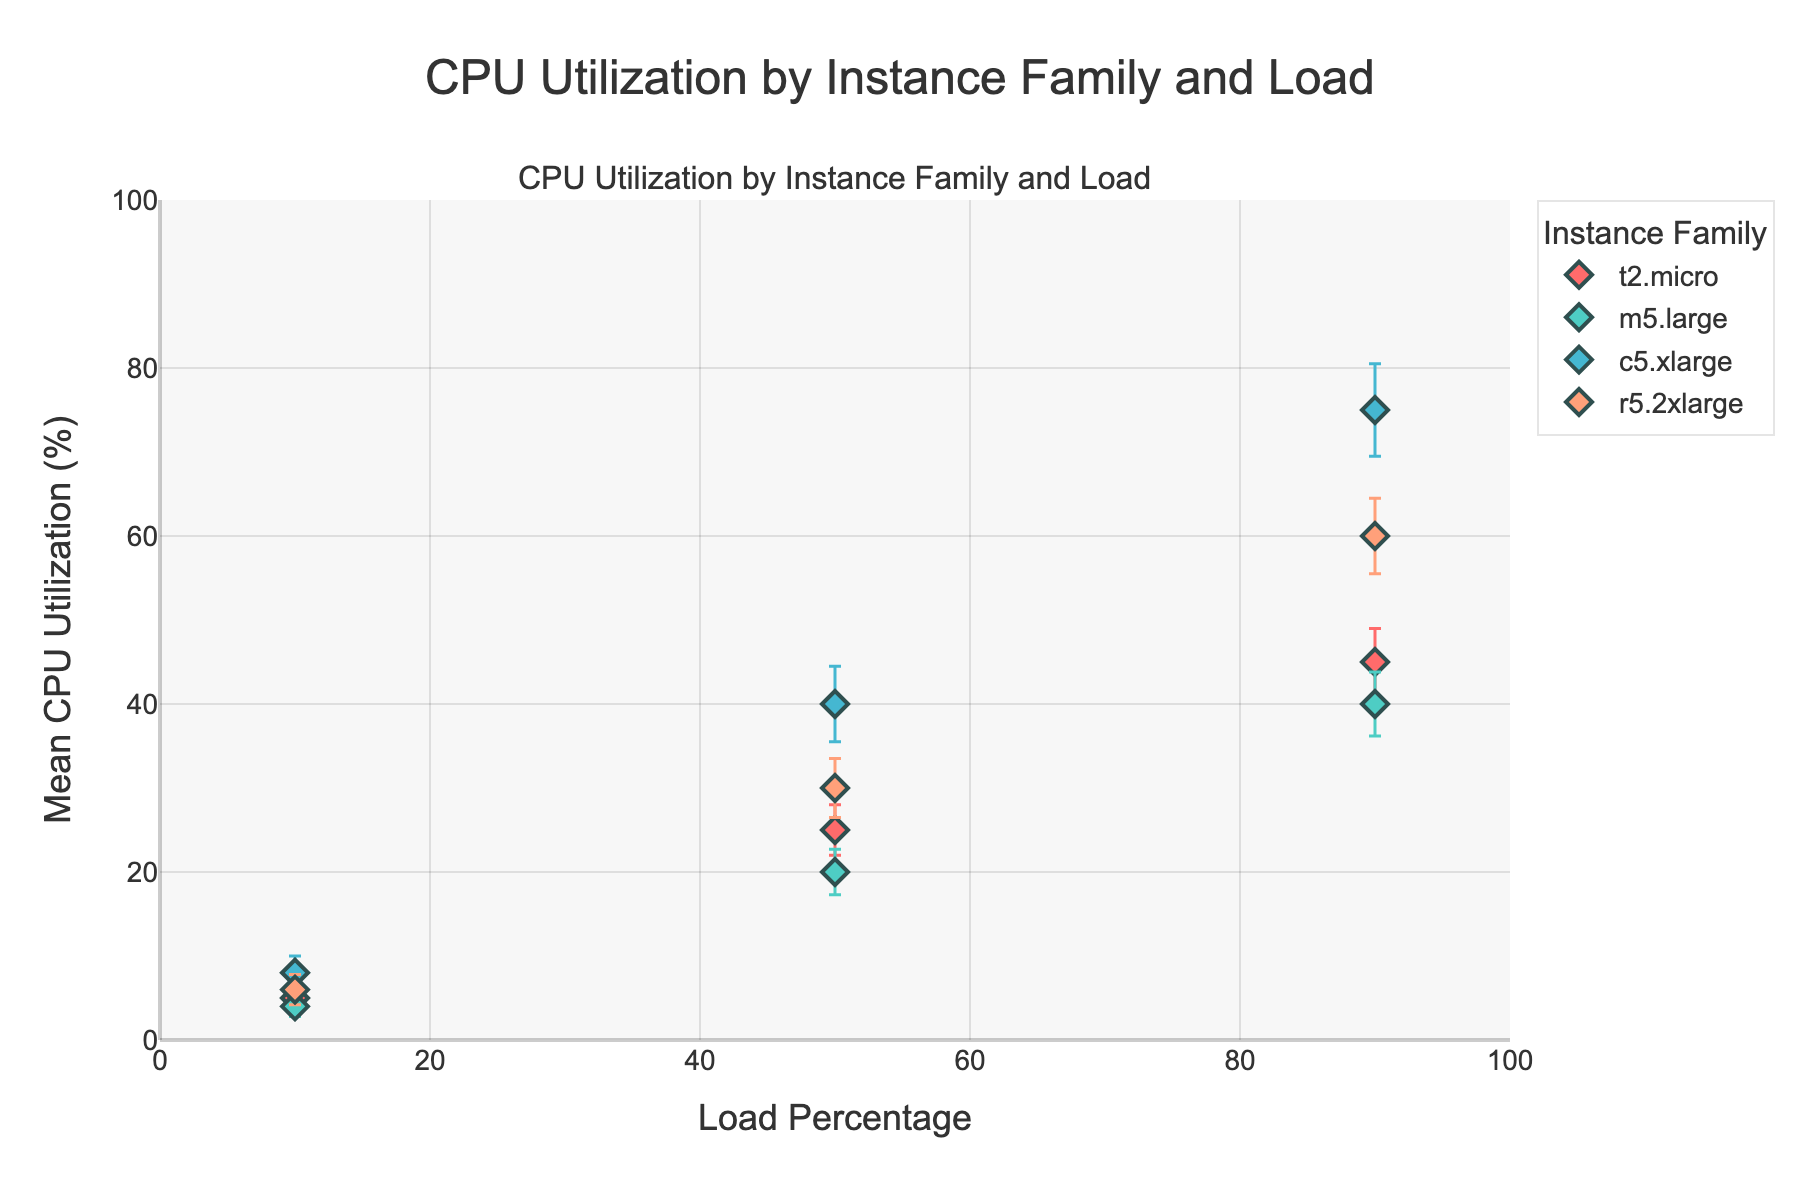What's the title of the plot? The title is displayed at the top of the plot and is usually a concise description of what the plot represents. In this case, it is given in the code.
Answer: CPU Utilization by Instance Family and Load What is the x-axis label? The x-axis label is provided under the horizontal axis of the plot, describing the data it represents. According to the code, it specifies the load percentage.
Answer: Load Percentage Which instance family shows the highest mean CPU utilization at 90% load? To determine this, look at the plotted points for the 90% load on the x-axis and find the highest y-coordinate among them.
Answer: c5.xlarge What is the mean CPU utilization for an m5.large instance at 10% load? Look for the data point associated with the m5.large instance family at 10% load on the plot. The y-value of this point represents the mean CPU utilization.
Answer: 4% Compare the CPU utilization of t2.micro and r5.2xlarge at 50% load. Which is higher? Locate the points for t2.micro and r5.2xlarge at 50% load on the x-axis and compare their y-values.
Answer: r5.2xlarge Which instance family has the smallest confidence interval at 10% load? Look at the error bars at 10% load and identify the shortest one, which represents the smallest confidence interval.
Answer: m5.large What is the difference in mean CPU utilization between c5.xlarge and r5.2xlarge at 90% load? Find the y-values for c5.xlarge and r5.2xlarge at 90% load and compute the difference.
Answer: 15% How does the confidence interval for the t2.micro instance at 50% load compare to that at 90% load? Compare the length of the error bars for t2.micro at 50% and 90% loads.
Answer: Larger at 90% What overall trend can you observe in CPU utilization as load percentage increases? Observe the general direction of the points and error bars on the plot.
Answer: Increases Which instance family has a consistently linear CPU utilization increase as load percentage increases? Evaluate the y-values of each instance family across different loads to determine which one shows a linear trend.
Answer: m5.large 